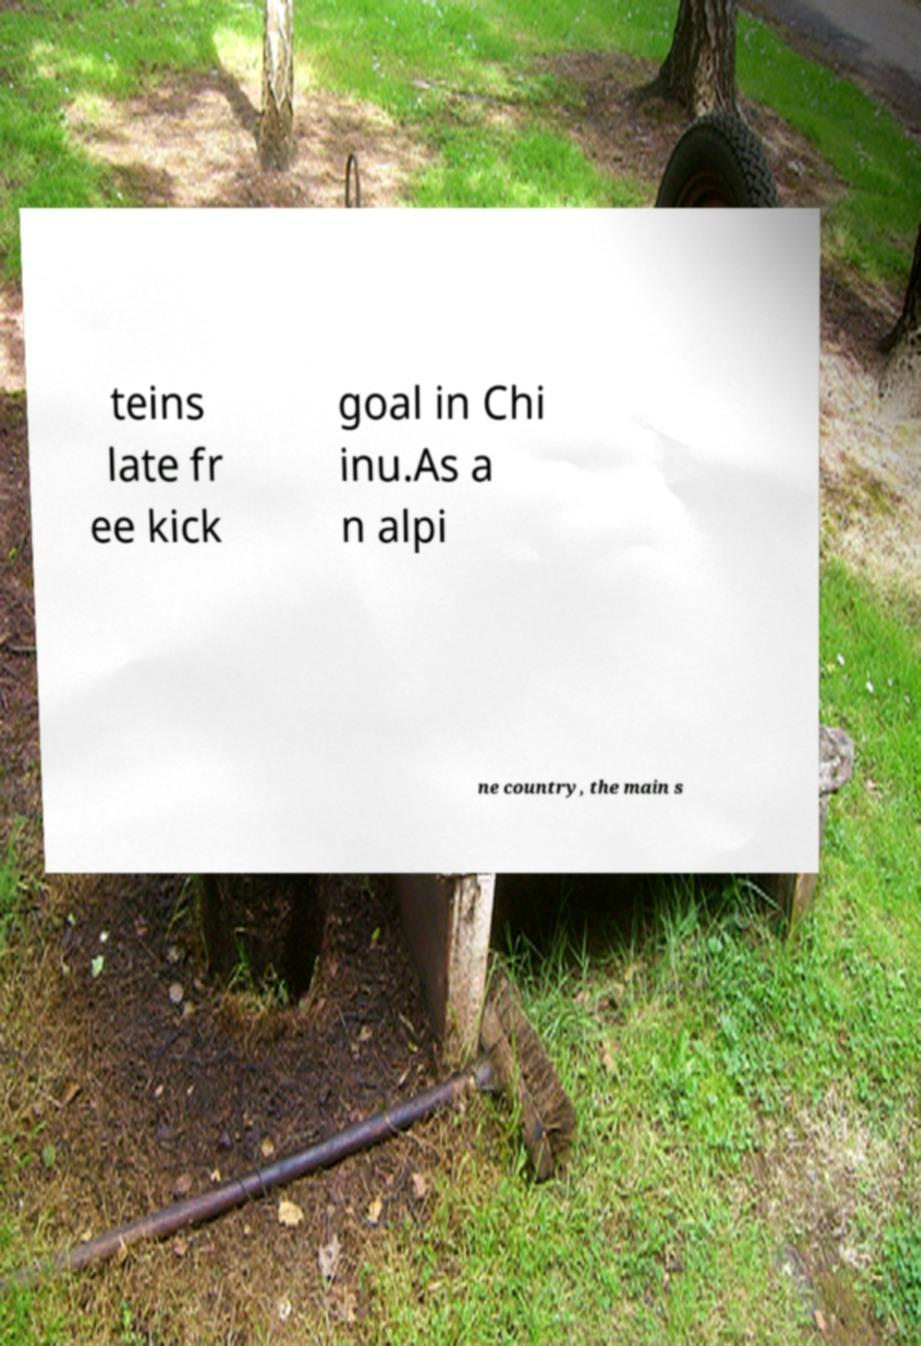Could you extract and type out the text from this image? teins late fr ee kick goal in Chi inu.As a n alpi ne country, the main s 